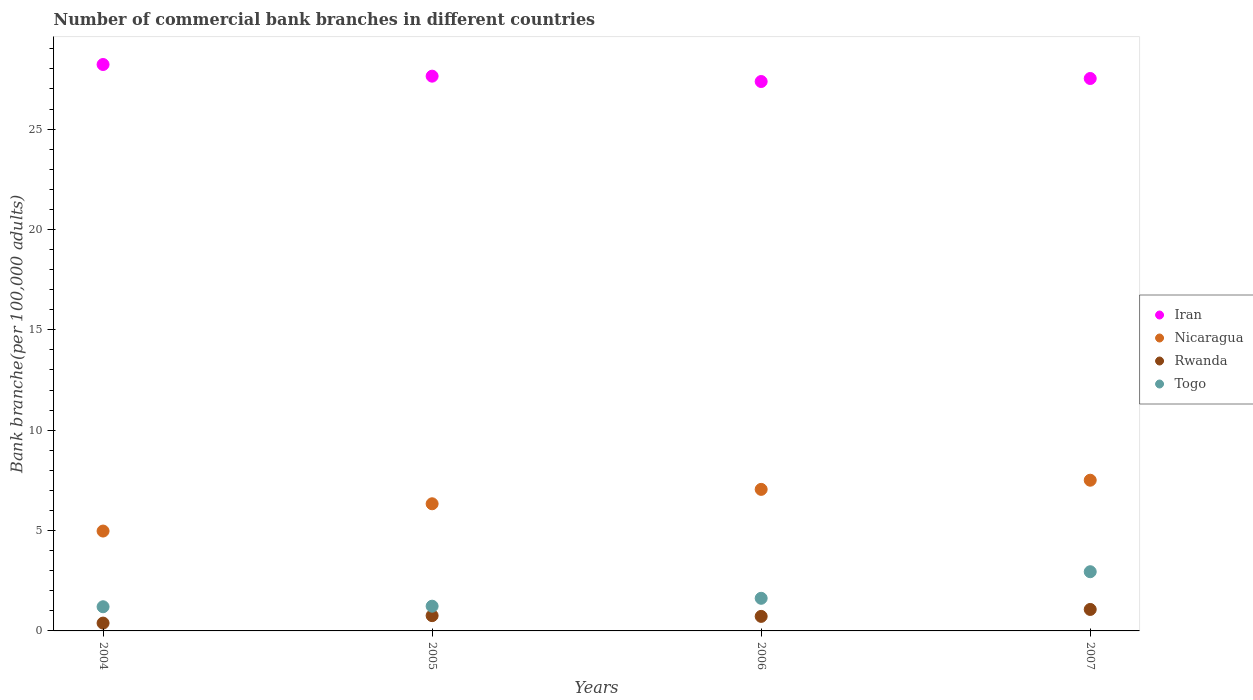What is the number of commercial bank branches in Rwanda in 2004?
Keep it short and to the point. 0.39. Across all years, what is the maximum number of commercial bank branches in Iran?
Offer a terse response. 28.22. Across all years, what is the minimum number of commercial bank branches in Togo?
Your answer should be very brief. 1.2. In which year was the number of commercial bank branches in Rwanda minimum?
Your response must be concise. 2004. What is the total number of commercial bank branches in Iran in the graph?
Ensure brevity in your answer.  110.74. What is the difference between the number of commercial bank branches in Rwanda in 2004 and that in 2006?
Your answer should be very brief. -0.33. What is the difference between the number of commercial bank branches in Togo in 2006 and the number of commercial bank branches in Nicaragua in 2005?
Offer a very short reply. -4.71. What is the average number of commercial bank branches in Nicaragua per year?
Provide a succinct answer. 6.47. In the year 2007, what is the difference between the number of commercial bank branches in Nicaragua and number of commercial bank branches in Togo?
Provide a short and direct response. 4.56. In how many years, is the number of commercial bank branches in Iran greater than 4?
Your answer should be very brief. 4. What is the ratio of the number of commercial bank branches in Iran in 2004 to that in 2007?
Provide a succinct answer. 1.03. Is the difference between the number of commercial bank branches in Nicaragua in 2006 and 2007 greater than the difference between the number of commercial bank branches in Togo in 2006 and 2007?
Give a very brief answer. Yes. What is the difference between the highest and the second highest number of commercial bank branches in Nicaragua?
Ensure brevity in your answer.  0.46. What is the difference between the highest and the lowest number of commercial bank branches in Iran?
Offer a terse response. 0.85. In how many years, is the number of commercial bank branches in Togo greater than the average number of commercial bank branches in Togo taken over all years?
Ensure brevity in your answer.  1. Is it the case that in every year, the sum of the number of commercial bank branches in Rwanda and number of commercial bank branches in Iran  is greater than the sum of number of commercial bank branches in Nicaragua and number of commercial bank branches in Togo?
Your response must be concise. Yes. Is it the case that in every year, the sum of the number of commercial bank branches in Togo and number of commercial bank branches in Iran  is greater than the number of commercial bank branches in Rwanda?
Keep it short and to the point. Yes. Is the number of commercial bank branches in Nicaragua strictly less than the number of commercial bank branches in Iran over the years?
Provide a short and direct response. Yes. How many years are there in the graph?
Your answer should be compact. 4. Are the values on the major ticks of Y-axis written in scientific E-notation?
Your response must be concise. No. What is the title of the graph?
Provide a short and direct response. Number of commercial bank branches in different countries. Does "Andorra" appear as one of the legend labels in the graph?
Provide a succinct answer. No. What is the label or title of the X-axis?
Make the answer very short. Years. What is the label or title of the Y-axis?
Provide a short and direct response. Bank branche(per 100,0 adults). What is the Bank branche(per 100,000 adults) of Iran in 2004?
Offer a terse response. 28.22. What is the Bank branche(per 100,000 adults) in Nicaragua in 2004?
Provide a short and direct response. 4.97. What is the Bank branche(per 100,000 adults) in Rwanda in 2004?
Offer a terse response. 0.39. What is the Bank branche(per 100,000 adults) of Togo in 2004?
Ensure brevity in your answer.  1.2. What is the Bank branche(per 100,000 adults) in Iran in 2005?
Provide a succinct answer. 27.64. What is the Bank branche(per 100,000 adults) of Nicaragua in 2005?
Keep it short and to the point. 6.33. What is the Bank branche(per 100,000 adults) of Rwanda in 2005?
Make the answer very short. 0.76. What is the Bank branche(per 100,000 adults) in Togo in 2005?
Your answer should be compact. 1.23. What is the Bank branche(per 100,000 adults) in Iran in 2006?
Provide a succinct answer. 27.37. What is the Bank branche(per 100,000 adults) of Nicaragua in 2006?
Offer a very short reply. 7.05. What is the Bank branche(per 100,000 adults) of Rwanda in 2006?
Keep it short and to the point. 0.72. What is the Bank branche(per 100,000 adults) in Togo in 2006?
Your answer should be compact. 1.63. What is the Bank branche(per 100,000 adults) in Iran in 2007?
Give a very brief answer. 27.52. What is the Bank branche(per 100,000 adults) of Nicaragua in 2007?
Ensure brevity in your answer.  7.51. What is the Bank branche(per 100,000 adults) of Rwanda in 2007?
Offer a terse response. 1.07. What is the Bank branche(per 100,000 adults) in Togo in 2007?
Your answer should be very brief. 2.95. Across all years, what is the maximum Bank branche(per 100,000 adults) in Iran?
Your answer should be very brief. 28.22. Across all years, what is the maximum Bank branche(per 100,000 adults) in Nicaragua?
Give a very brief answer. 7.51. Across all years, what is the maximum Bank branche(per 100,000 adults) in Rwanda?
Your answer should be compact. 1.07. Across all years, what is the maximum Bank branche(per 100,000 adults) in Togo?
Offer a terse response. 2.95. Across all years, what is the minimum Bank branche(per 100,000 adults) in Iran?
Your answer should be very brief. 27.37. Across all years, what is the minimum Bank branche(per 100,000 adults) in Nicaragua?
Your answer should be very brief. 4.97. Across all years, what is the minimum Bank branche(per 100,000 adults) of Rwanda?
Ensure brevity in your answer.  0.39. Across all years, what is the minimum Bank branche(per 100,000 adults) in Togo?
Offer a very short reply. 1.2. What is the total Bank branche(per 100,000 adults) in Iran in the graph?
Offer a very short reply. 110.74. What is the total Bank branche(per 100,000 adults) of Nicaragua in the graph?
Offer a terse response. 25.87. What is the total Bank branche(per 100,000 adults) in Rwanda in the graph?
Your response must be concise. 2.94. What is the total Bank branche(per 100,000 adults) in Togo in the graph?
Keep it short and to the point. 7.01. What is the difference between the Bank branche(per 100,000 adults) of Iran in 2004 and that in 2005?
Provide a short and direct response. 0.58. What is the difference between the Bank branche(per 100,000 adults) in Nicaragua in 2004 and that in 2005?
Give a very brief answer. -1.36. What is the difference between the Bank branche(per 100,000 adults) in Rwanda in 2004 and that in 2005?
Provide a succinct answer. -0.37. What is the difference between the Bank branche(per 100,000 adults) in Togo in 2004 and that in 2005?
Your answer should be very brief. -0.03. What is the difference between the Bank branche(per 100,000 adults) in Iran in 2004 and that in 2006?
Provide a short and direct response. 0.85. What is the difference between the Bank branche(per 100,000 adults) in Nicaragua in 2004 and that in 2006?
Ensure brevity in your answer.  -2.08. What is the difference between the Bank branche(per 100,000 adults) of Rwanda in 2004 and that in 2006?
Provide a short and direct response. -0.33. What is the difference between the Bank branche(per 100,000 adults) of Togo in 2004 and that in 2006?
Your answer should be very brief. -0.42. What is the difference between the Bank branche(per 100,000 adults) of Iran in 2004 and that in 2007?
Offer a terse response. 0.7. What is the difference between the Bank branche(per 100,000 adults) of Nicaragua in 2004 and that in 2007?
Your answer should be compact. -2.53. What is the difference between the Bank branche(per 100,000 adults) in Rwanda in 2004 and that in 2007?
Your answer should be very brief. -0.68. What is the difference between the Bank branche(per 100,000 adults) in Togo in 2004 and that in 2007?
Your answer should be compact. -1.75. What is the difference between the Bank branche(per 100,000 adults) in Iran in 2005 and that in 2006?
Your response must be concise. 0.27. What is the difference between the Bank branche(per 100,000 adults) in Nicaragua in 2005 and that in 2006?
Keep it short and to the point. -0.72. What is the difference between the Bank branche(per 100,000 adults) of Rwanda in 2005 and that in 2006?
Keep it short and to the point. 0.04. What is the difference between the Bank branche(per 100,000 adults) in Togo in 2005 and that in 2006?
Provide a succinct answer. -0.39. What is the difference between the Bank branche(per 100,000 adults) in Iran in 2005 and that in 2007?
Your answer should be very brief. 0.12. What is the difference between the Bank branche(per 100,000 adults) in Nicaragua in 2005 and that in 2007?
Offer a terse response. -1.17. What is the difference between the Bank branche(per 100,000 adults) of Rwanda in 2005 and that in 2007?
Ensure brevity in your answer.  -0.31. What is the difference between the Bank branche(per 100,000 adults) in Togo in 2005 and that in 2007?
Offer a terse response. -1.72. What is the difference between the Bank branche(per 100,000 adults) in Iran in 2006 and that in 2007?
Ensure brevity in your answer.  -0.15. What is the difference between the Bank branche(per 100,000 adults) in Nicaragua in 2006 and that in 2007?
Make the answer very short. -0.46. What is the difference between the Bank branche(per 100,000 adults) of Rwanda in 2006 and that in 2007?
Ensure brevity in your answer.  -0.35. What is the difference between the Bank branche(per 100,000 adults) of Togo in 2006 and that in 2007?
Give a very brief answer. -1.32. What is the difference between the Bank branche(per 100,000 adults) in Iran in 2004 and the Bank branche(per 100,000 adults) in Nicaragua in 2005?
Offer a terse response. 21.88. What is the difference between the Bank branche(per 100,000 adults) of Iran in 2004 and the Bank branche(per 100,000 adults) of Rwanda in 2005?
Your response must be concise. 27.46. What is the difference between the Bank branche(per 100,000 adults) of Iran in 2004 and the Bank branche(per 100,000 adults) of Togo in 2005?
Provide a short and direct response. 26.99. What is the difference between the Bank branche(per 100,000 adults) of Nicaragua in 2004 and the Bank branche(per 100,000 adults) of Rwanda in 2005?
Keep it short and to the point. 4.21. What is the difference between the Bank branche(per 100,000 adults) of Nicaragua in 2004 and the Bank branche(per 100,000 adults) of Togo in 2005?
Offer a very short reply. 3.74. What is the difference between the Bank branche(per 100,000 adults) of Rwanda in 2004 and the Bank branche(per 100,000 adults) of Togo in 2005?
Offer a terse response. -0.84. What is the difference between the Bank branche(per 100,000 adults) of Iran in 2004 and the Bank branche(per 100,000 adults) of Nicaragua in 2006?
Offer a very short reply. 21.17. What is the difference between the Bank branche(per 100,000 adults) in Iran in 2004 and the Bank branche(per 100,000 adults) in Rwanda in 2006?
Offer a very short reply. 27.49. What is the difference between the Bank branche(per 100,000 adults) in Iran in 2004 and the Bank branche(per 100,000 adults) in Togo in 2006?
Give a very brief answer. 26.59. What is the difference between the Bank branche(per 100,000 adults) in Nicaragua in 2004 and the Bank branche(per 100,000 adults) in Rwanda in 2006?
Your response must be concise. 4.25. What is the difference between the Bank branche(per 100,000 adults) of Nicaragua in 2004 and the Bank branche(per 100,000 adults) of Togo in 2006?
Your answer should be compact. 3.35. What is the difference between the Bank branche(per 100,000 adults) of Rwanda in 2004 and the Bank branche(per 100,000 adults) of Togo in 2006?
Offer a very short reply. -1.24. What is the difference between the Bank branche(per 100,000 adults) in Iran in 2004 and the Bank branche(per 100,000 adults) in Nicaragua in 2007?
Your response must be concise. 20.71. What is the difference between the Bank branche(per 100,000 adults) in Iran in 2004 and the Bank branche(per 100,000 adults) in Rwanda in 2007?
Provide a short and direct response. 27.15. What is the difference between the Bank branche(per 100,000 adults) of Iran in 2004 and the Bank branche(per 100,000 adults) of Togo in 2007?
Keep it short and to the point. 25.27. What is the difference between the Bank branche(per 100,000 adults) in Nicaragua in 2004 and the Bank branche(per 100,000 adults) in Rwanda in 2007?
Provide a short and direct response. 3.9. What is the difference between the Bank branche(per 100,000 adults) of Nicaragua in 2004 and the Bank branche(per 100,000 adults) of Togo in 2007?
Keep it short and to the point. 2.03. What is the difference between the Bank branche(per 100,000 adults) of Rwanda in 2004 and the Bank branche(per 100,000 adults) of Togo in 2007?
Offer a very short reply. -2.56. What is the difference between the Bank branche(per 100,000 adults) of Iran in 2005 and the Bank branche(per 100,000 adults) of Nicaragua in 2006?
Offer a terse response. 20.58. What is the difference between the Bank branche(per 100,000 adults) in Iran in 2005 and the Bank branche(per 100,000 adults) in Rwanda in 2006?
Make the answer very short. 26.91. What is the difference between the Bank branche(per 100,000 adults) of Iran in 2005 and the Bank branche(per 100,000 adults) of Togo in 2006?
Ensure brevity in your answer.  26.01. What is the difference between the Bank branche(per 100,000 adults) in Nicaragua in 2005 and the Bank branche(per 100,000 adults) in Rwanda in 2006?
Your answer should be compact. 5.61. What is the difference between the Bank branche(per 100,000 adults) of Nicaragua in 2005 and the Bank branche(per 100,000 adults) of Togo in 2006?
Your answer should be compact. 4.71. What is the difference between the Bank branche(per 100,000 adults) in Rwanda in 2005 and the Bank branche(per 100,000 adults) in Togo in 2006?
Provide a succinct answer. -0.86. What is the difference between the Bank branche(per 100,000 adults) in Iran in 2005 and the Bank branche(per 100,000 adults) in Nicaragua in 2007?
Keep it short and to the point. 20.13. What is the difference between the Bank branche(per 100,000 adults) of Iran in 2005 and the Bank branche(per 100,000 adults) of Rwanda in 2007?
Your answer should be compact. 26.57. What is the difference between the Bank branche(per 100,000 adults) of Iran in 2005 and the Bank branche(per 100,000 adults) of Togo in 2007?
Your response must be concise. 24.69. What is the difference between the Bank branche(per 100,000 adults) of Nicaragua in 2005 and the Bank branche(per 100,000 adults) of Rwanda in 2007?
Provide a succinct answer. 5.26. What is the difference between the Bank branche(per 100,000 adults) in Nicaragua in 2005 and the Bank branche(per 100,000 adults) in Togo in 2007?
Give a very brief answer. 3.38. What is the difference between the Bank branche(per 100,000 adults) in Rwanda in 2005 and the Bank branche(per 100,000 adults) in Togo in 2007?
Your answer should be very brief. -2.19. What is the difference between the Bank branche(per 100,000 adults) in Iran in 2006 and the Bank branche(per 100,000 adults) in Nicaragua in 2007?
Make the answer very short. 19.86. What is the difference between the Bank branche(per 100,000 adults) in Iran in 2006 and the Bank branche(per 100,000 adults) in Rwanda in 2007?
Provide a succinct answer. 26.3. What is the difference between the Bank branche(per 100,000 adults) in Iran in 2006 and the Bank branche(per 100,000 adults) in Togo in 2007?
Keep it short and to the point. 24.42. What is the difference between the Bank branche(per 100,000 adults) of Nicaragua in 2006 and the Bank branche(per 100,000 adults) of Rwanda in 2007?
Provide a succinct answer. 5.98. What is the difference between the Bank branche(per 100,000 adults) in Nicaragua in 2006 and the Bank branche(per 100,000 adults) in Togo in 2007?
Ensure brevity in your answer.  4.1. What is the difference between the Bank branche(per 100,000 adults) of Rwanda in 2006 and the Bank branche(per 100,000 adults) of Togo in 2007?
Ensure brevity in your answer.  -2.23. What is the average Bank branche(per 100,000 adults) of Iran per year?
Your answer should be compact. 27.69. What is the average Bank branche(per 100,000 adults) of Nicaragua per year?
Make the answer very short. 6.47. What is the average Bank branche(per 100,000 adults) of Rwanda per year?
Your response must be concise. 0.74. What is the average Bank branche(per 100,000 adults) of Togo per year?
Provide a succinct answer. 1.75. In the year 2004, what is the difference between the Bank branche(per 100,000 adults) of Iran and Bank branche(per 100,000 adults) of Nicaragua?
Your answer should be very brief. 23.24. In the year 2004, what is the difference between the Bank branche(per 100,000 adults) of Iran and Bank branche(per 100,000 adults) of Rwanda?
Offer a very short reply. 27.83. In the year 2004, what is the difference between the Bank branche(per 100,000 adults) of Iran and Bank branche(per 100,000 adults) of Togo?
Offer a terse response. 27.01. In the year 2004, what is the difference between the Bank branche(per 100,000 adults) in Nicaragua and Bank branche(per 100,000 adults) in Rwanda?
Make the answer very short. 4.58. In the year 2004, what is the difference between the Bank branche(per 100,000 adults) in Nicaragua and Bank branche(per 100,000 adults) in Togo?
Ensure brevity in your answer.  3.77. In the year 2004, what is the difference between the Bank branche(per 100,000 adults) of Rwanda and Bank branche(per 100,000 adults) of Togo?
Your response must be concise. -0.81. In the year 2005, what is the difference between the Bank branche(per 100,000 adults) of Iran and Bank branche(per 100,000 adults) of Nicaragua?
Make the answer very short. 21.3. In the year 2005, what is the difference between the Bank branche(per 100,000 adults) in Iran and Bank branche(per 100,000 adults) in Rwanda?
Keep it short and to the point. 26.88. In the year 2005, what is the difference between the Bank branche(per 100,000 adults) in Iran and Bank branche(per 100,000 adults) in Togo?
Ensure brevity in your answer.  26.4. In the year 2005, what is the difference between the Bank branche(per 100,000 adults) in Nicaragua and Bank branche(per 100,000 adults) in Rwanda?
Keep it short and to the point. 5.57. In the year 2005, what is the difference between the Bank branche(per 100,000 adults) in Nicaragua and Bank branche(per 100,000 adults) in Togo?
Offer a very short reply. 5.1. In the year 2005, what is the difference between the Bank branche(per 100,000 adults) of Rwanda and Bank branche(per 100,000 adults) of Togo?
Provide a short and direct response. -0.47. In the year 2006, what is the difference between the Bank branche(per 100,000 adults) of Iran and Bank branche(per 100,000 adults) of Nicaragua?
Make the answer very short. 20.32. In the year 2006, what is the difference between the Bank branche(per 100,000 adults) of Iran and Bank branche(per 100,000 adults) of Rwanda?
Offer a very short reply. 26.65. In the year 2006, what is the difference between the Bank branche(per 100,000 adults) of Iran and Bank branche(per 100,000 adults) of Togo?
Make the answer very short. 25.74. In the year 2006, what is the difference between the Bank branche(per 100,000 adults) of Nicaragua and Bank branche(per 100,000 adults) of Rwanda?
Make the answer very short. 6.33. In the year 2006, what is the difference between the Bank branche(per 100,000 adults) of Nicaragua and Bank branche(per 100,000 adults) of Togo?
Your answer should be compact. 5.43. In the year 2006, what is the difference between the Bank branche(per 100,000 adults) of Rwanda and Bank branche(per 100,000 adults) of Togo?
Your response must be concise. -0.9. In the year 2007, what is the difference between the Bank branche(per 100,000 adults) of Iran and Bank branche(per 100,000 adults) of Nicaragua?
Make the answer very short. 20.01. In the year 2007, what is the difference between the Bank branche(per 100,000 adults) of Iran and Bank branche(per 100,000 adults) of Rwanda?
Your answer should be very brief. 26.45. In the year 2007, what is the difference between the Bank branche(per 100,000 adults) in Iran and Bank branche(per 100,000 adults) in Togo?
Your response must be concise. 24.57. In the year 2007, what is the difference between the Bank branche(per 100,000 adults) in Nicaragua and Bank branche(per 100,000 adults) in Rwanda?
Offer a terse response. 6.44. In the year 2007, what is the difference between the Bank branche(per 100,000 adults) of Nicaragua and Bank branche(per 100,000 adults) of Togo?
Offer a very short reply. 4.56. In the year 2007, what is the difference between the Bank branche(per 100,000 adults) in Rwanda and Bank branche(per 100,000 adults) in Togo?
Keep it short and to the point. -1.88. What is the ratio of the Bank branche(per 100,000 adults) of Iran in 2004 to that in 2005?
Offer a terse response. 1.02. What is the ratio of the Bank branche(per 100,000 adults) in Nicaragua in 2004 to that in 2005?
Make the answer very short. 0.79. What is the ratio of the Bank branche(per 100,000 adults) in Rwanda in 2004 to that in 2005?
Ensure brevity in your answer.  0.51. What is the ratio of the Bank branche(per 100,000 adults) of Togo in 2004 to that in 2005?
Keep it short and to the point. 0.98. What is the ratio of the Bank branche(per 100,000 adults) in Iran in 2004 to that in 2006?
Offer a terse response. 1.03. What is the ratio of the Bank branche(per 100,000 adults) in Nicaragua in 2004 to that in 2006?
Give a very brief answer. 0.71. What is the ratio of the Bank branche(per 100,000 adults) of Rwanda in 2004 to that in 2006?
Your response must be concise. 0.54. What is the ratio of the Bank branche(per 100,000 adults) of Togo in 2004 to that in 2006?
Ensure brevity in your answer.  0.74. What is the ratio of the Bank branche(per 100,000 adults) of Iran in 2004 to that in 2007?
Your response must be concise. 1.03. What is the ratio of the Bank branche(per 100,000 adults) of Nicaragua in 2004 to that in 2007?
Make the answer very short. 0.66. What is the ratio of the Bank branche(per 100,000 adults) of Rwanda in 2004 to that in 2007?
Make the answer very short. 0.36. What is the ratio of the Bank branche(per 100,000 adults) of Togo in 2004 to that in 2007?
Offer a terse response. 0.41. What is the ratio of the Bank branche(per 100,000 adults) of Iran in 2005 to that in 2006?
Your answer should be very brief. 1.01. What is the ratio of the Bank branche(per 100,000 adults) in Nicaragua in 2005 to that in 2006?
Your answer should be compact. 0.9. What is the ratio of the Bank branche(per 100,000 adults) in Rwanda in 2005 to that in 2006?
Your answer should be compact. 1.05. What is the ratio of the Bank branche(per 100,000 adults) in Togo in 2005 to that in 2006?
Ensure brevity in your answer.  0.76. What is the ratio of the Bank branche(per 100,000 adults) in Nicaragua in 2005 to that in 2007?
Your answer should be compact. 0.84. What is the ratio of the Bank branche(per 100,000 adults) in Rwanda in 2005 to that in 2007?
Offer a very short reply. 0.71. What is the ratio of the Bank branche(per 100,000 adults) of Togo in 2005 to that in 2007?
Offer a terse response. 0.42. What is the ratio of the Bank branche(per 100,000 adults) in Nicaragua in 2006 to that in 2007?
Your response must be concise. 0.94. What is the ratio of the Bank branche(per 100,000 adults) in Rwanda in 2006 to that in 2007?
Your answer should be very brief. 0.68. What is the ratio of the Bank branche(per 100,000 adults) of Togo in 2006 to that in 2007?
Give a very brief answer. 0.55. What is the difference between the highest and the second highest Bank branche(per 100,000 adults) in Iran?
Your response must be concise. 0.58. What is the difference between the highest and the second highest Bank branche(per 100,000 adults) of Nicaragua?
Offer a terse response. 0.46. What is the difference between the highest and the second highest Bank branche(per 100,000 adults) in Rwanda?
Keep it short and to the point. 0.31. What is the difference between the highest and the second highest Bank branche(per 100,000 adults) of Togo?
Your response must be concise. 1.32. What is the difference between the highest and the lowest Bank branche(per 100,000 adults) in Iran?
Offer a very short reply. 0.85. What is the difference between the highest and the lowest Bank branche(per 100,000 adults) in Nicaragua?
Ensure brevity in your answer.  2.53. What is the difference between the highest and the lowest Bank branche(per 100,000 adults) in Rwanda?
Offer a terse response. 0.68. What is the difference between the highest and the lowest Bank branche(per 100,000 adults) of Togo?
Your response must be concise. 1.75. 